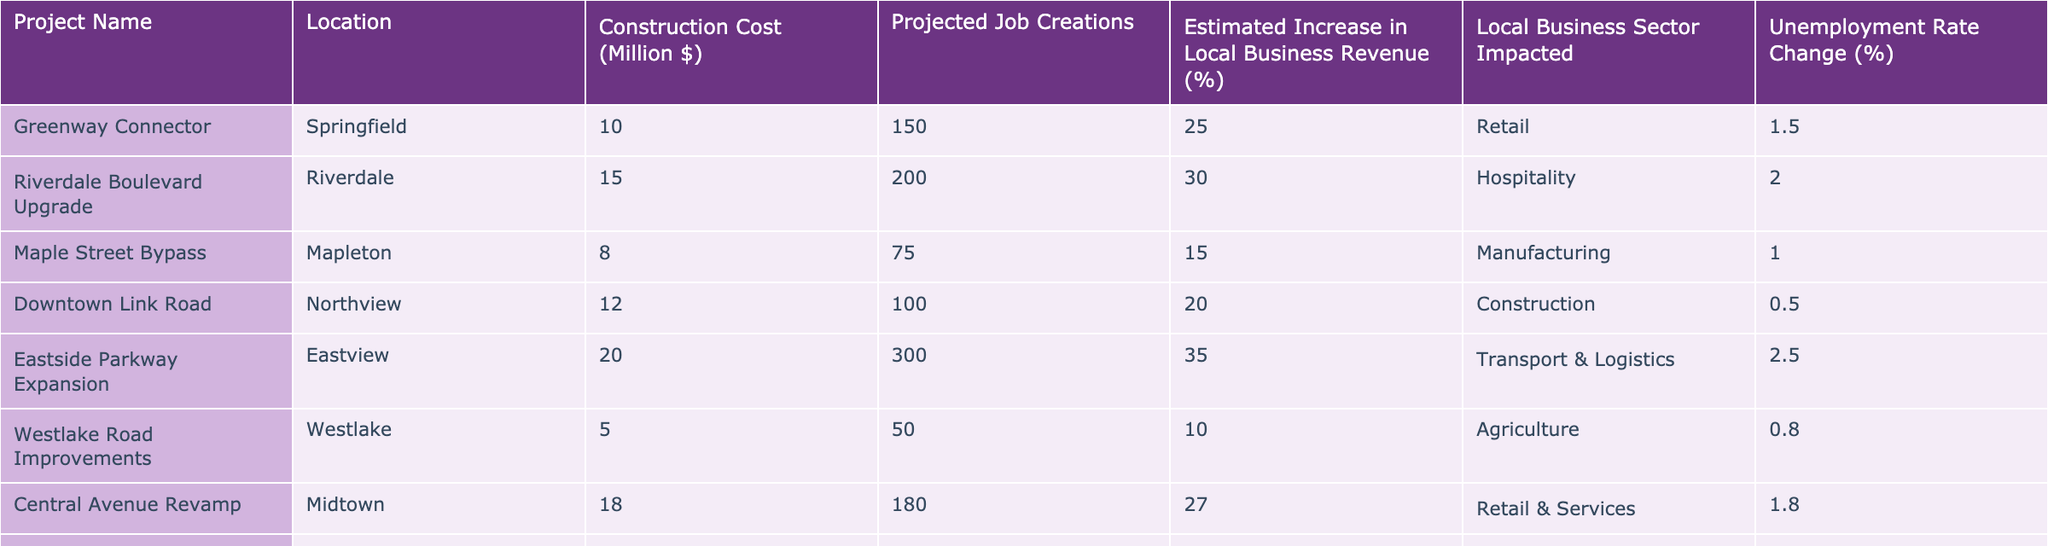What is the projected job creation for the Maple Street Bypass project? The table shows the projected job creation for the Maple Street Bypass project in the "Projected Job Creations" column. It states 75 jobs are expected to be created.
Answer: 75 Which project has the highest estimated increase in local business revenue? By examining the "Estimated Increase in Local Business Revenue (%)" column, we can see that the North Valley Highway Enhancement project has the highest percentage at 40%.
Answer: 40% What is the total construction cost for all projects listed? To find the total construction cost, we sum the values in the "Construction Cost (Million $)" column: 10 + 15 + 8 + 12 + 20 + 5 + 18 + 25 = 113 million dollars.
Answer: 113 million $ Is the unemployment rate change for Eastside Parkway Expansion positive? The unemployment rate change for Eastside Parkway Expansion is listed as 2.5%, which is a positive value indicating an expected decrease in unemployment.
Answer: Yes Which project has the lowest projected job creation, and what is that number? The "Projected Job Creations" column reveals that the Westlake Road Improvements project has the lowest at 50 projected jobs.
Answer: 50 What is the average increase in local business revenue across all projects? To calculate the average, sum the percentage increases: (25 + 30 + 15 + 20 + 35 + 10 + 27 + 40) = 202. There are 8 projects, so the average is 202/8 = 25.25%.
Answer: 25.25% Does the Downtown Link Road project have a higher estimated increase in local business revenue than the Maple Street Bypass? The estimated increases are 20% for Downtown Link Road and 15% for Maple Street Bypass. Since 20% is greater than 15%, the answer is yes.
Answer: Yes How many projects are expected to create over 100 jobs? Looking at the "Projected Job Creations" column, the projects with over 100 jobs are: Riverdale Boulevard Upgrade (200), Eastside Parkway Expansion (300), Central Avenue Revamp (180), and North Valley Highway Enhancement (400). This totals to 4 projects.
Answer: 4 What is the change in unemployment rate for the Riverdale Boulevard Upgrade? The table indicates that the unemployment rate change for the Riverdale Boulevard Upgrade project is 2.0%. This represents a decrease in unemployment.
Answer: 2.0% 